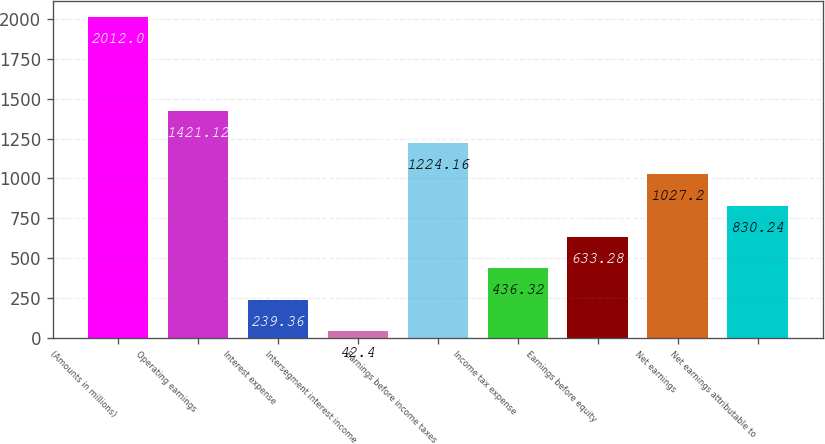<chart> <loc_0><loc_0><loc_500><loc_500><bar_chart><fcel>(Amounts in millions)<fcel>Operating earnings<fcel>Interest expense<fcel>Intersegment interest income<fcel>Earnings before income taxes<fcel>Income tax expense<fcel>Earnings before equity<fcel>Net earnings<fcel>Net earnings attributable to<nl><fcel>2012<fcel>1421.12<fcel>239.36<fcel>42.4<fcel>1224.16<fcel>436.32<fcel>633.28<fcel>1027.2<fcel>830.24<nl></chart> 